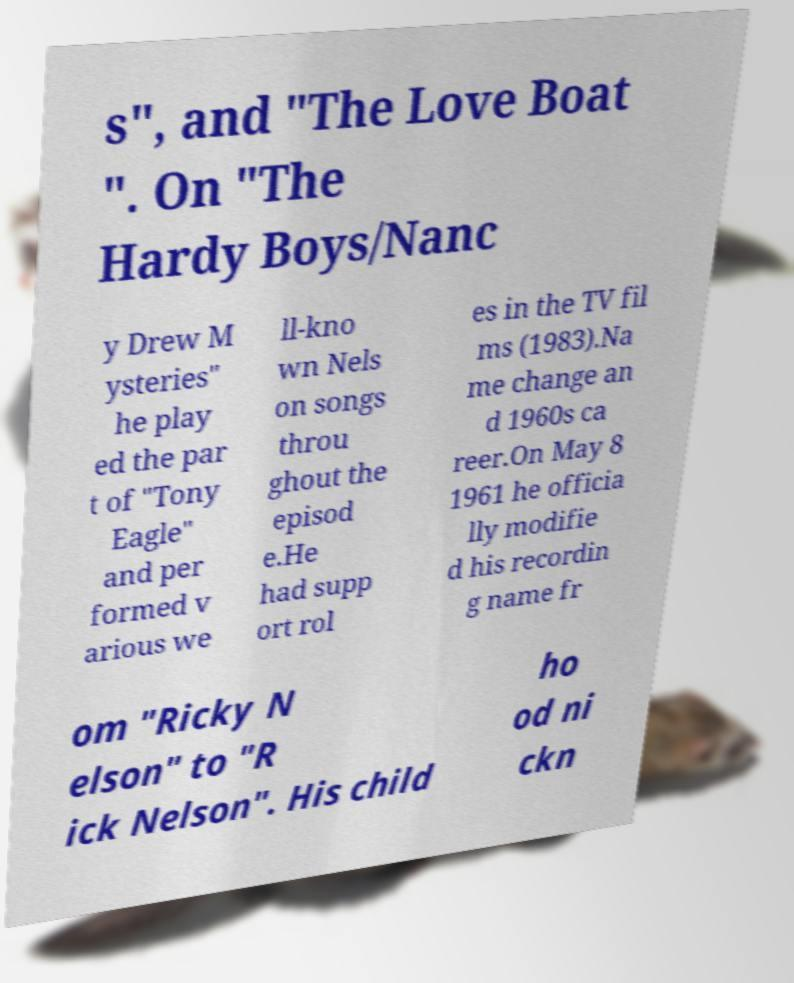Could you extract and type out the text from this image? s", and "The Love Boat ". On "The Hardy Boys/Nanc y Drew M ysteries" he play ed the par t of "Tony Eagle" and per formed v arious we ll-kno wn Nels on songs throu ghout the episod e.He had supp ort rol es in the TV fil ms (1983).Na me change an d 1960s ca reer.On May 8 1961 he officia lly modifie d his recordin g name fr om "Ricky N elson" to "R ick Nelson". His child ho od ni ckn 